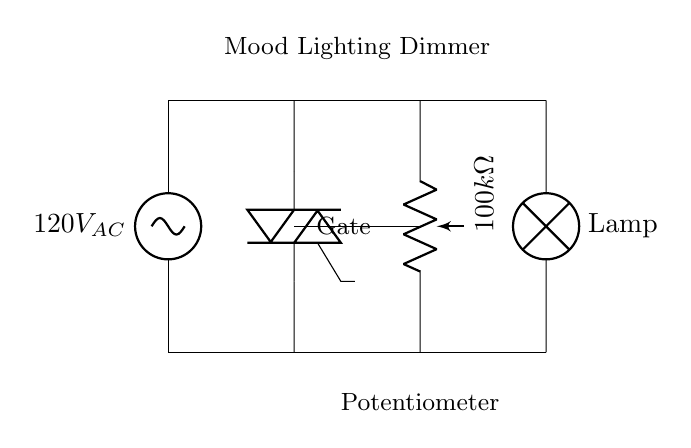What is the voltage source type in this circuit? The circuit diagram shows an AC voltage source indicated as 120V_AC, which specifies that the voltage source is alternating current.
Answer: AC What component is used to control the light intensity? The circuit features a potentiometer labeled as 100kΩ. A potentiometer is used to adjust the resistance and, consequently, the brightness of the lamp by varying the voltage across it.
Answer: Potentiometer What is the purpose of the TRIAC in this circuit? The TRIAC is used to control the power to the lamp, allowing for dimming the light by adjusting the phase angle of the AC current. This is a common application of TRIACs in lighting control.
Answer: Dimming What is the resistance value of the potentiometer used? The potentiometer in the diagram is labeled as 100kΩ, indicating its resistance value which is critical for the light dimming functionality.
Answer: 100kΩ Which component connects to the lamp in this circuit? The lamp is connected directly to the TRIAC and the power source, indicating it is controlled by these components for operation.
Answer: TRIAC What is the current direction indicated in the diagram? The AC source provides current in both directions, but the design allows the TRIAC to control current flow to the lamp when activated, meaning it can conduct current in both halves of the AC cycle.
Answer: Bidirectional How is the gate of the TRIAC connected in the circuit? The gate of the TRIAC is connected to the potentiometer, which allows the resistance adjustment to influence when the TRIAC turns on during the AC cycle, thus controlling the light output.
Answer: Potentiometer 